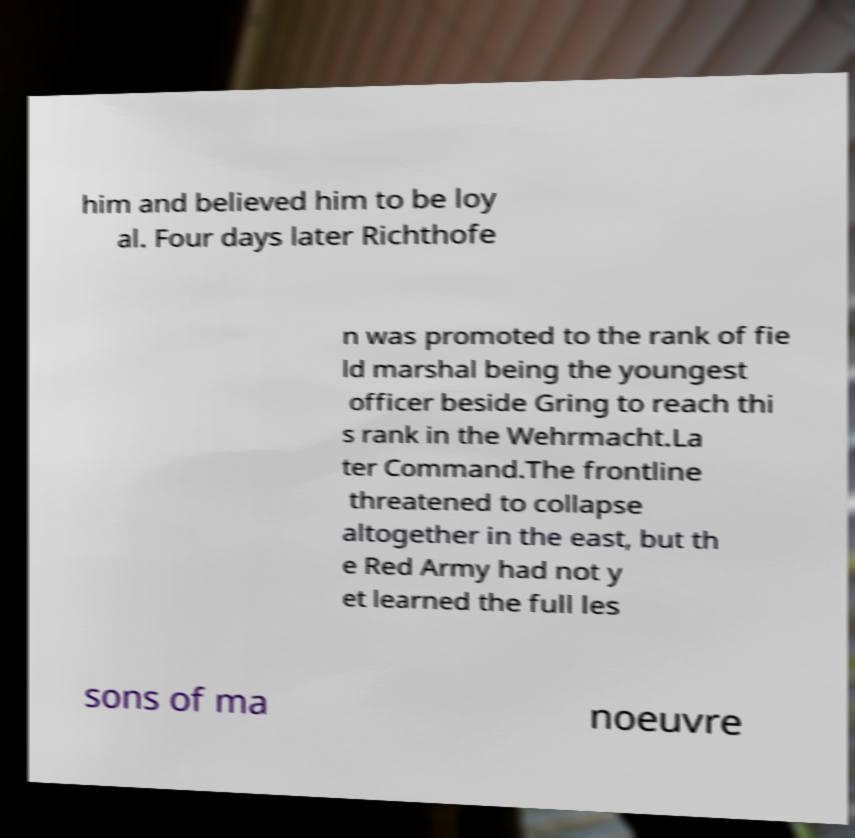Could you assist in decoding the text presented in this image and type it out clearly? him and believed him to be loy al. Four days later Richthofe n was promoted to the rank of fie ld marshal being the youngest officer beside Gring to reach thi s rank in the Wehrmacht.La ter Command.The frontline threatened to collapse altogether in the east, but th e Red Army had not y et learned the full les sons of ma noeuvre 